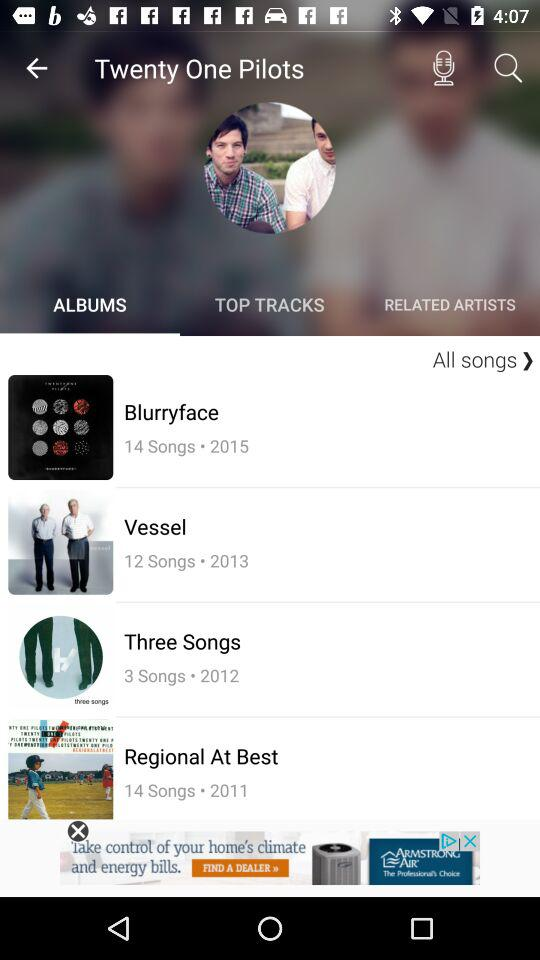How many more songs are on Regional At Best than on Three Songs?
Answer the question using a single word or phrase. 11 